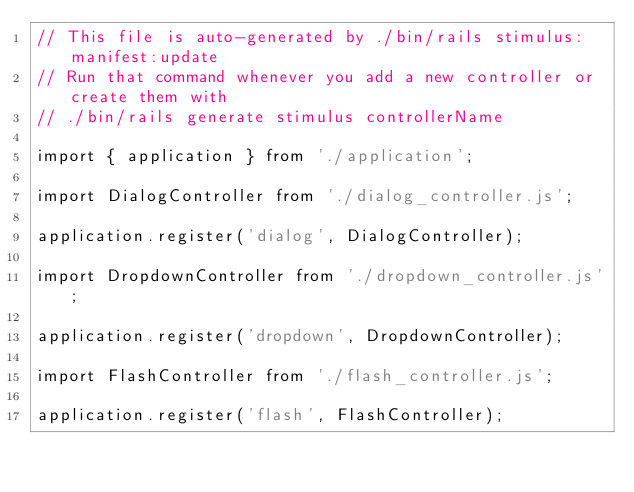Convert code to text. <code><loc_0><loc_0><loc_500><loc_500><_JavaScript_>// This file is auto-generated by ./bin/rails stimulus:manifest:update
// Run that command whenever you add a new controller or create them with
// ./bin/rails generate stimulus controllerName

import { application } from './application';

import DialogController from './dialog_controller.js';

application.register('dialog', DialogController);

import DropdownController from './dropdown_controller.js';

application.register('dropdown', DropdownController);

import FlashController from './flash_controller.js';

application.register('flash', FlashController);
</code> 